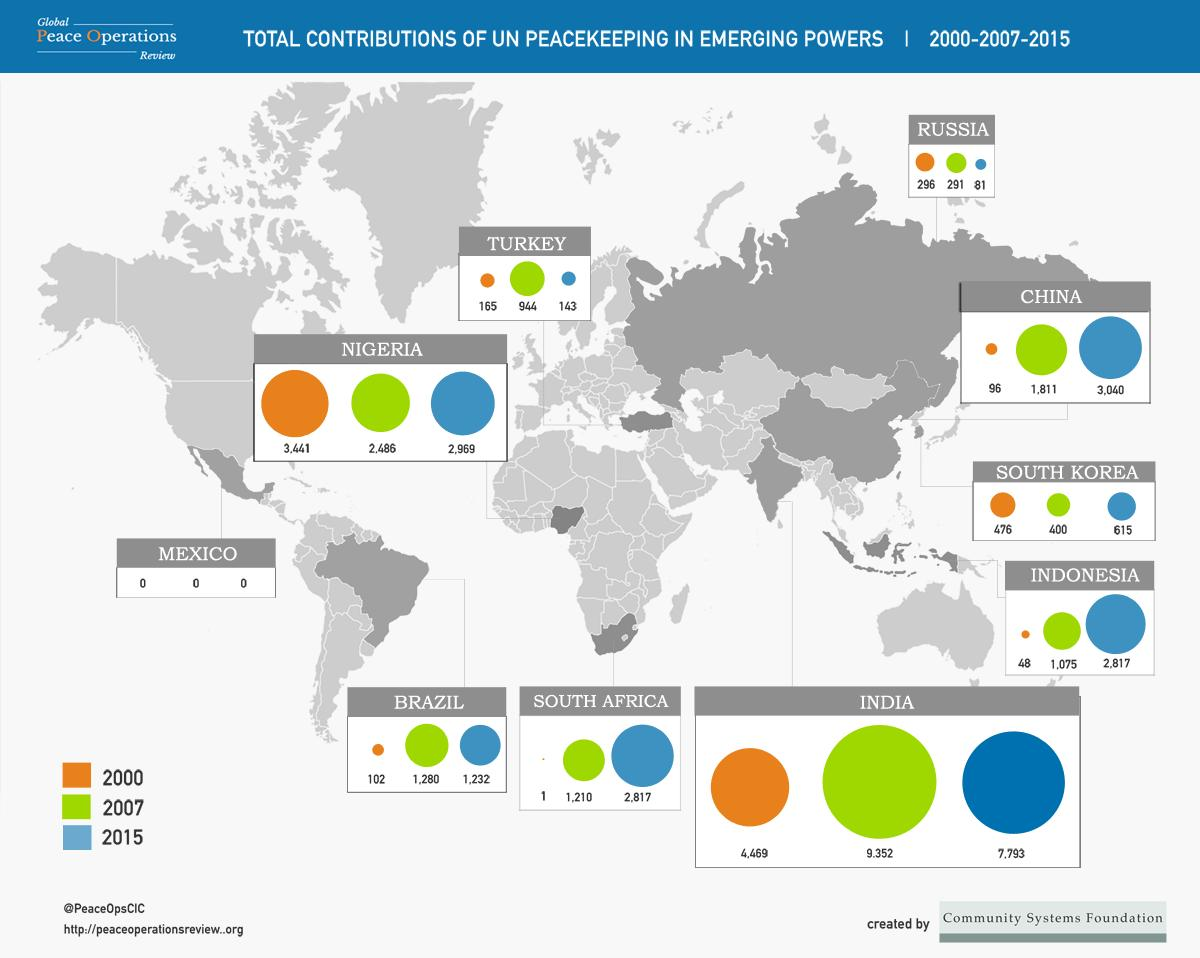Mention a couple of crucial points in this snapshot. The total period considered in this report is 15 years. The United Nations peacekeeping efforts in Nigeria in 2007 contributed significantly to the maintenance of peace and stability in the country. Other than India, several countries, including Russia, Turkey, and Brazil, have experienced a decline in 2015 when compared to 2007. In 2000, the contribution to Turkey's GDP was the second highest. The count of visitors from China to the United States increased by 2,944 from 2000 to 2015. 